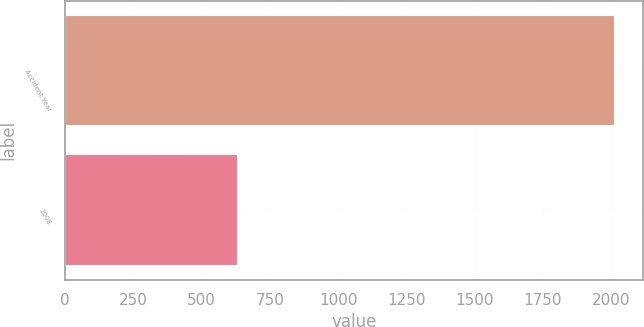Convert chart to OTSL. <chart><loc_0><loc_0><loc_500><loc_500><bar_chart><fcel>Accident Year<fcel>2008<nl><fcel>2014<fcel>633<nl></chart> 